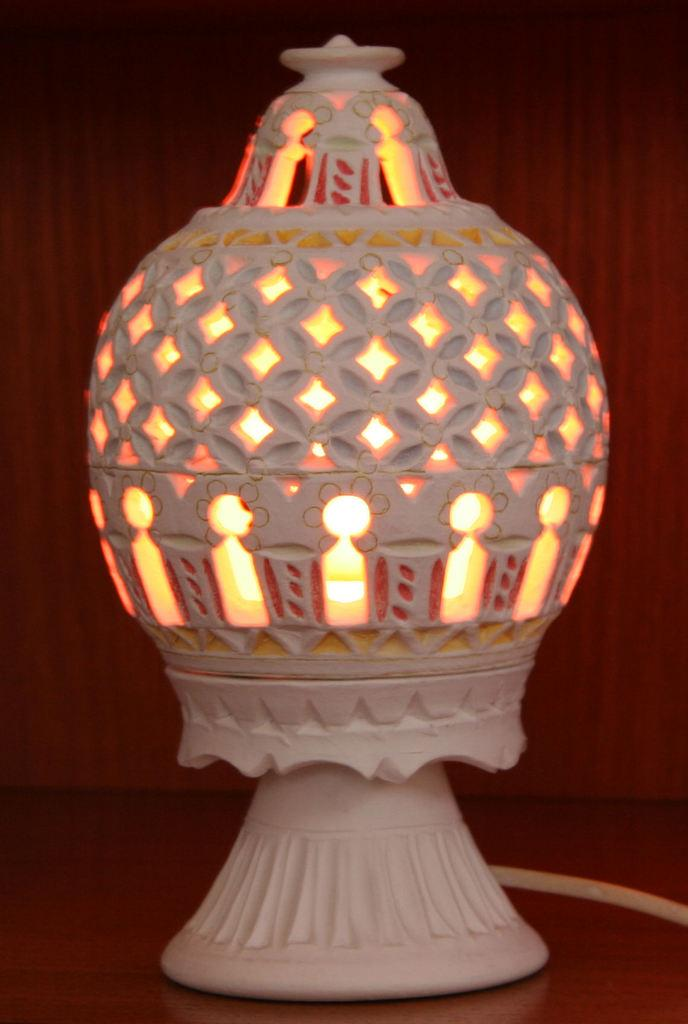What object can be seen in the image? There is a lamp in the image. On what surface is the lamp placed? The lamp is on a wooden surface. What type of wall is visible in the background of the image? There is a wooden wall in the background of the image. How many fish are swimming near the lamp in the image? There are no fish present in the image; it only features a lamp on a wooden surface and a wooden wall in the background. 